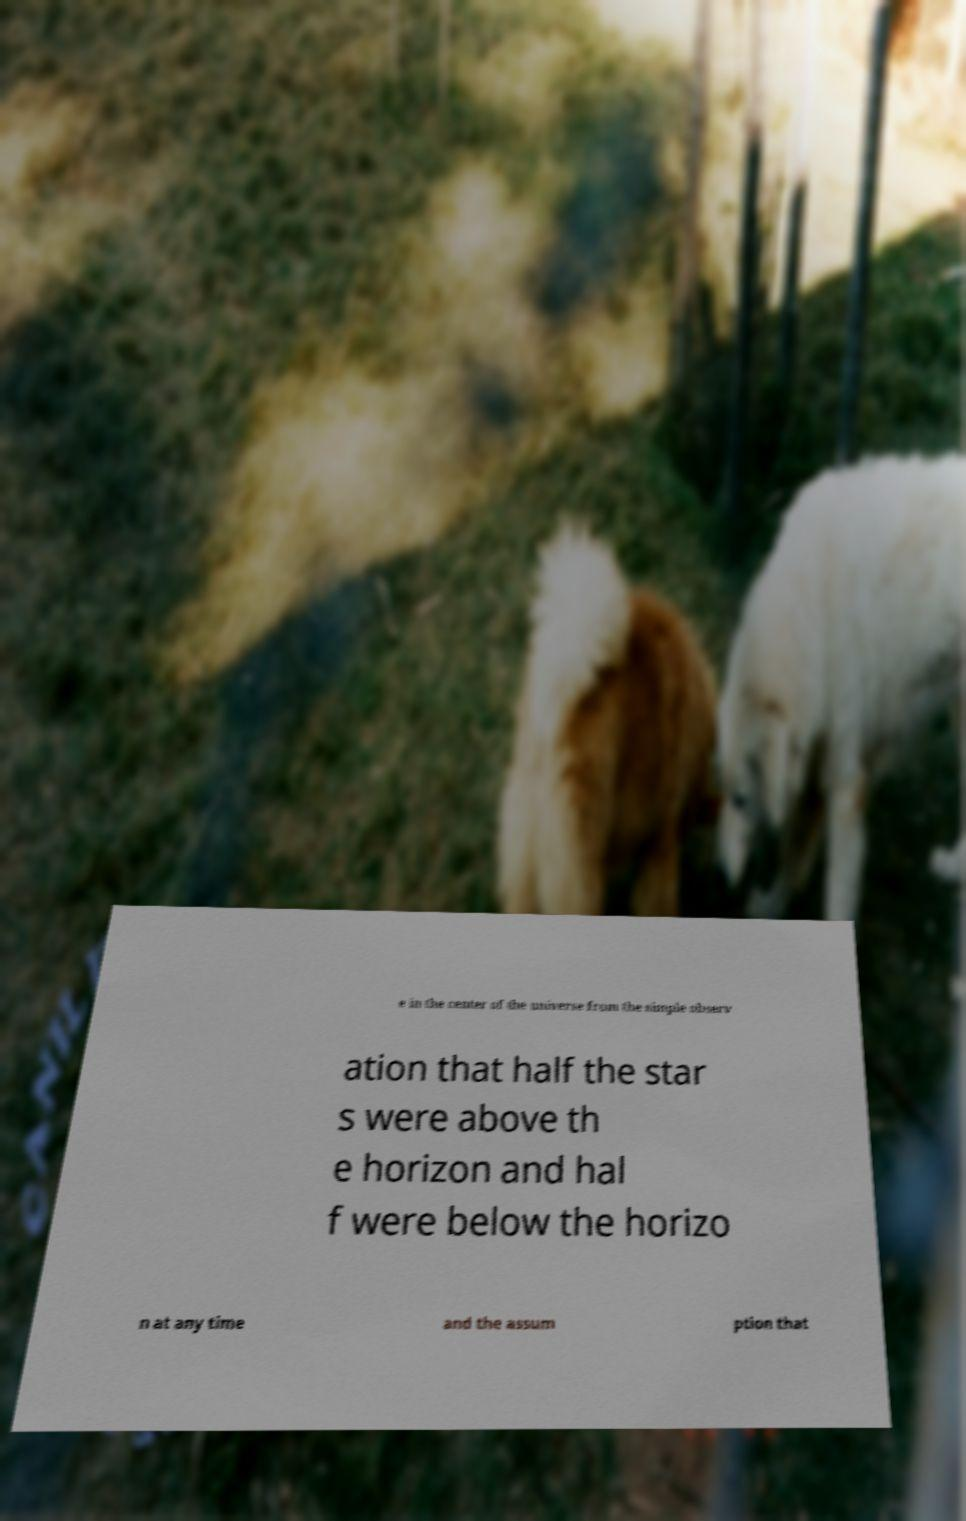I need the written content from this picture converted into text. Can you do that? e in the center of the universe from the simple observ ation that half the star s were above th e horizon and hal f were below the horizo n at any time and the assum ption that 